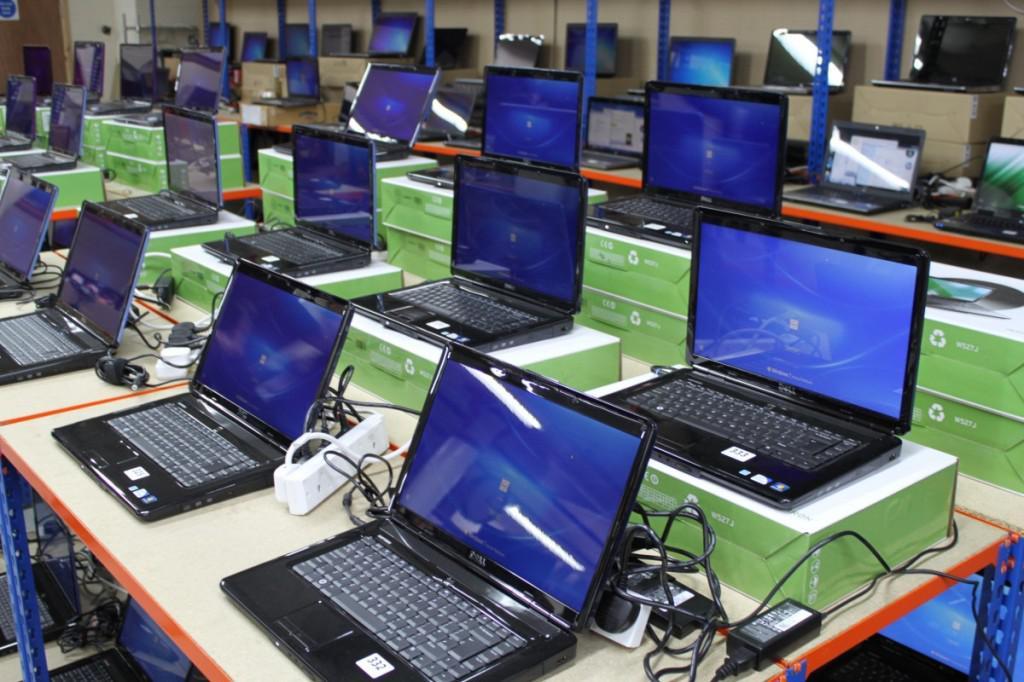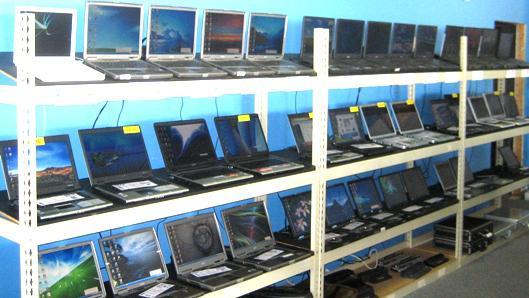The first image is the image on the left, the second image is the image on the right. Examine the images to the left and right. Is the description "An image shows a row of at least three open laptops, with screens angled facing rightward." accurate? Answer yes or no. No. The first image is the image on the left, the second image is the image on the right. For the images shown, is this caption "At least one image contains a single laptop." true? Answer yes or no. No. 